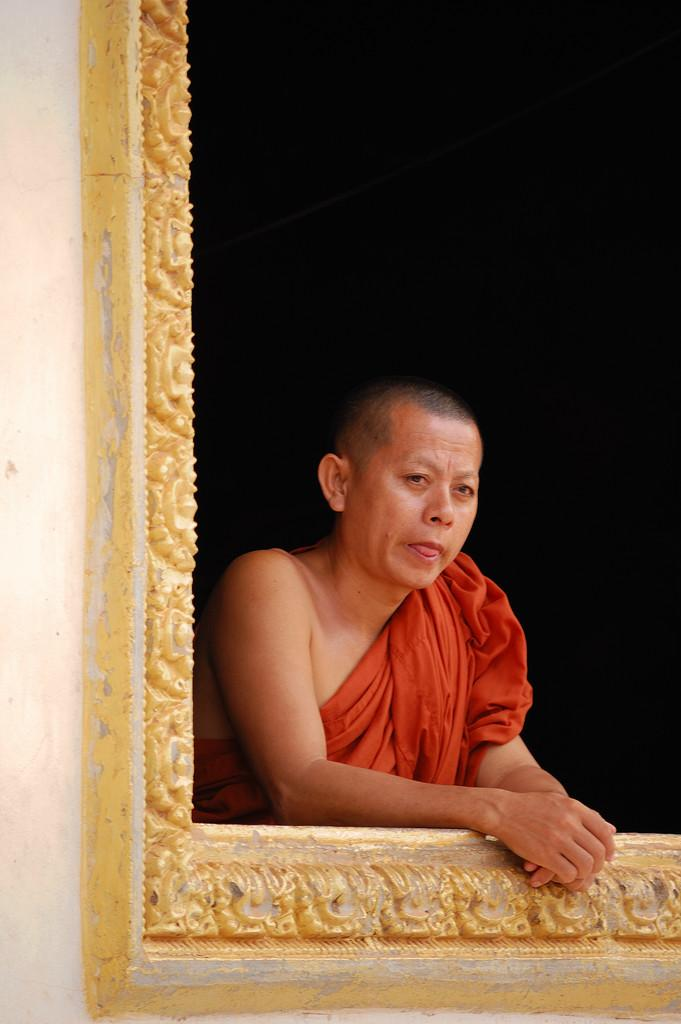Who or what is the main subject in the center of the image? There is a person in the center of the image. What is located in the foreground of the image? There is a wall in the foreground of the image. What can be seen on the wall? There are sculptures on the wall. What type of bead is being used to create the neck of the person in the image? There is no bead or neck visible in the image; it features a person in the center with a wall and sculptures in the foreground. 